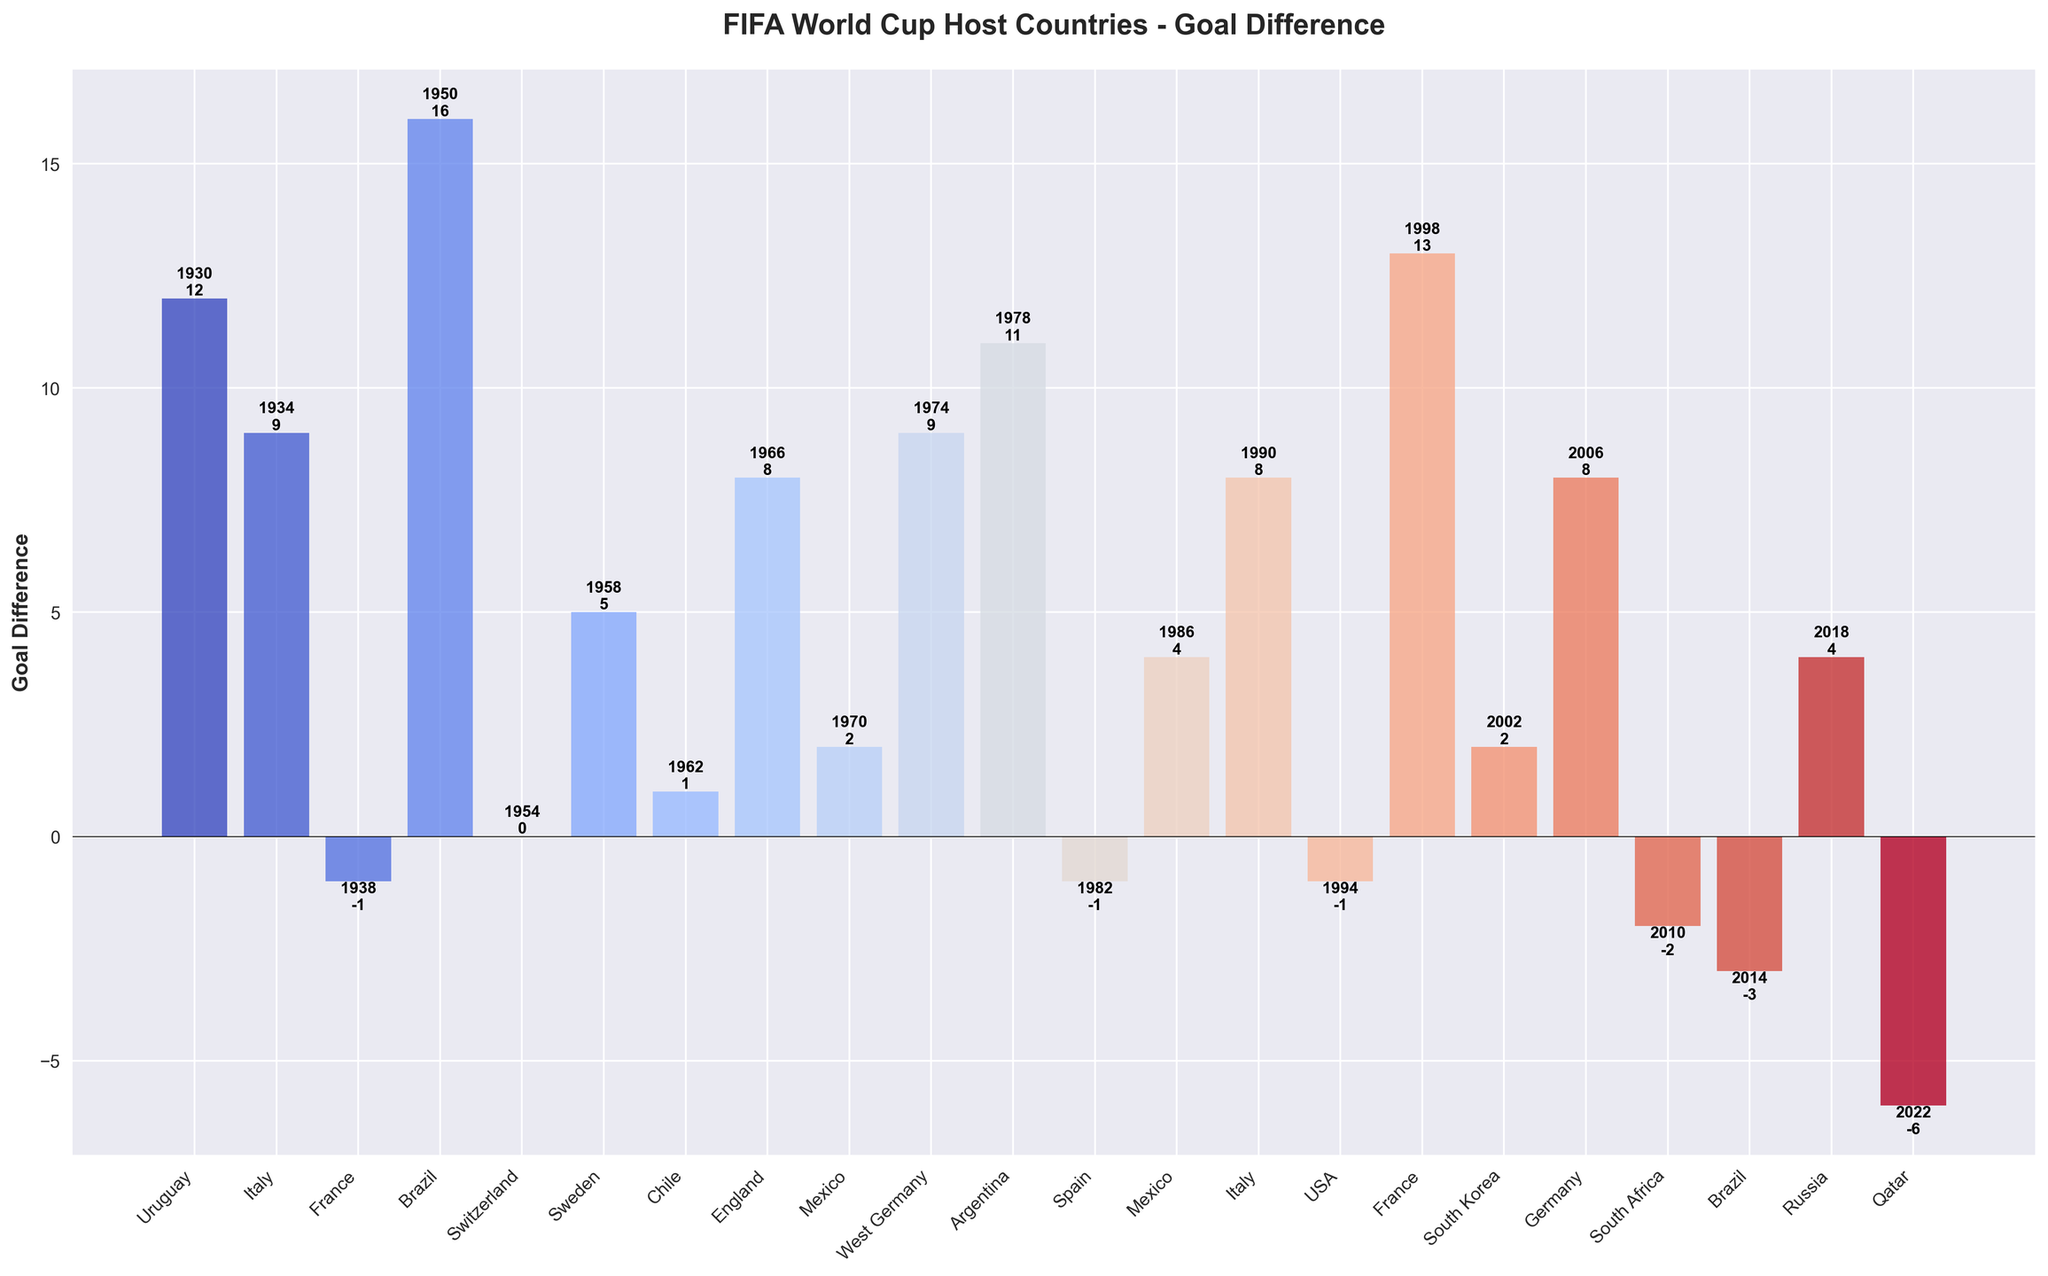Which host country had the highest goal difference, and what was their final position? The bar with the highest goal difference represents Uruguay, showing a goal difference of 12. Uruguay finished as Champions in the 1930 tournament.
Answer: Uruguay, Champions Which host country had the lowest goal difference, and how many goals did they score? The bar with the lowest goal difference represents Qatar, showing a goal difference of -6. They scored 1 goal in the 2022 tournament.
Answer: Qatar, 1 goal Compare the goal differences of Germany in 2006 and West Germany in 1974. Which one was higher and by how much? The goal difference for Germany in 2006 was 8, and for West Germany in 1974 was 9. West Germany had a higher goal difference by 1.
Answer: West Germany, by 1 How many host countries had a negative goal difference and what is the average goal difference among them? The countries with negative goal differences are France (1938, -1), Spain (1982, -1), USA (1994, -1), and Qatar (2022, -6). The average is calculated as (-1 + -1 + -1 + -6) / 4 = -2.25.
Answer: 4, -2.25 Which host countries finished in the group stage, and what were their goal differences? The host countries that finished in the group stage are South Africa (2010) with a goal difference of -2 and Qatar (2022) with a goal difference of -6.
Answer: South Africa: -2, Qatar: -6 What was the goal difference for the host country in the first World Cup, and how did this compare to the goal difference in the most recent World Cup? Uruguay in 1930 had a goal difference of 12, while Qatar in 2022 had a goal difference of -6. The difference between these two is 12 - (-6) = 18.
Answer: 18 Identify the host country with the biggest improvement in goal difference between two separate tournaments they hosted. What are the respective goal differences and years? Mexico hosted in 1970 with a goal difference of 2 and again in 1986 with a goal difference of 4. The improvement is 4 - 2 = 2.
Answer: Mexico, 2 Which host countries won the World Cup, and what were their respective goal differences? The host countries that won the World Cup are Uruguay (1930, 12), Italy (1934, 9), England (1966, 8), West Germany (1974, 9), Argentina (1978, 11), and France (1998, 13).
Answer: Uruguay: 12, Italy: 9, England: 8, West Germany: 9, Argentina: 11, France: 13 How many host countries had a goal difference of 0 or less, and list them along with their years? The host countries with a goal difference of 0 or less are Switzerland (1954, 0), France (1938, -1), Spain (1982, -1), USA (1994, -1), South Africa (2010, -2), Brazil (2014, -3), and Qatar (2022, -6).
Answer: 7: Switzerland (1954), France (1938), Spain (1982), USA (1994), South Africa (2010), Brazil (2014), Qatar (2022) 